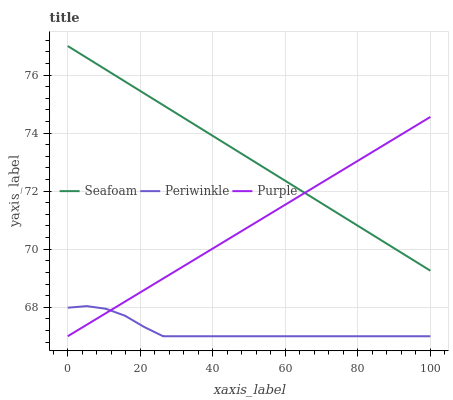Does Periwinkle have the minimum area under the curve?
Answer yes or no. Yes. Does Seafoam have the maximum area under the curve?
Answer yes or no. Yes. Does Seafoam have the minimum area under the curve?
Answer yes or no. No. Does Periwinkle have the maximum area under the curve?
Answer yes or no. No. Is Seafoam the smoothest?
Answer yes or no. Yes. Is Periwinkle the roughest?
Answer yes or no. Yes. Is Periwinkle the smoothest?
Answer yes or no. No. Is Seafoam the roughest?
Answer yes or no. No. Does Seafoam have the lowest value?
Answer yes or no. No. Does Seafoam have the highest value?
Answer yes or no. Yes. Does Periwinkle have the highest value?
Answer yes or no. No. Is Periwinkle less than Seafoam?
Answer yes or no. Yes. Is Seafoam greater than Periwinkle?
Answer yes or no. Yes. Does Seafoam intersect Purple?
Answer yes or no. Yes. Is Seafoam less than Purple?
Answer yes or no. No. Is Seafoam greater than Purple?
Answer yes or no. No. Does Periwinkle intersect Seafoam?
Answer yes or no. No. 